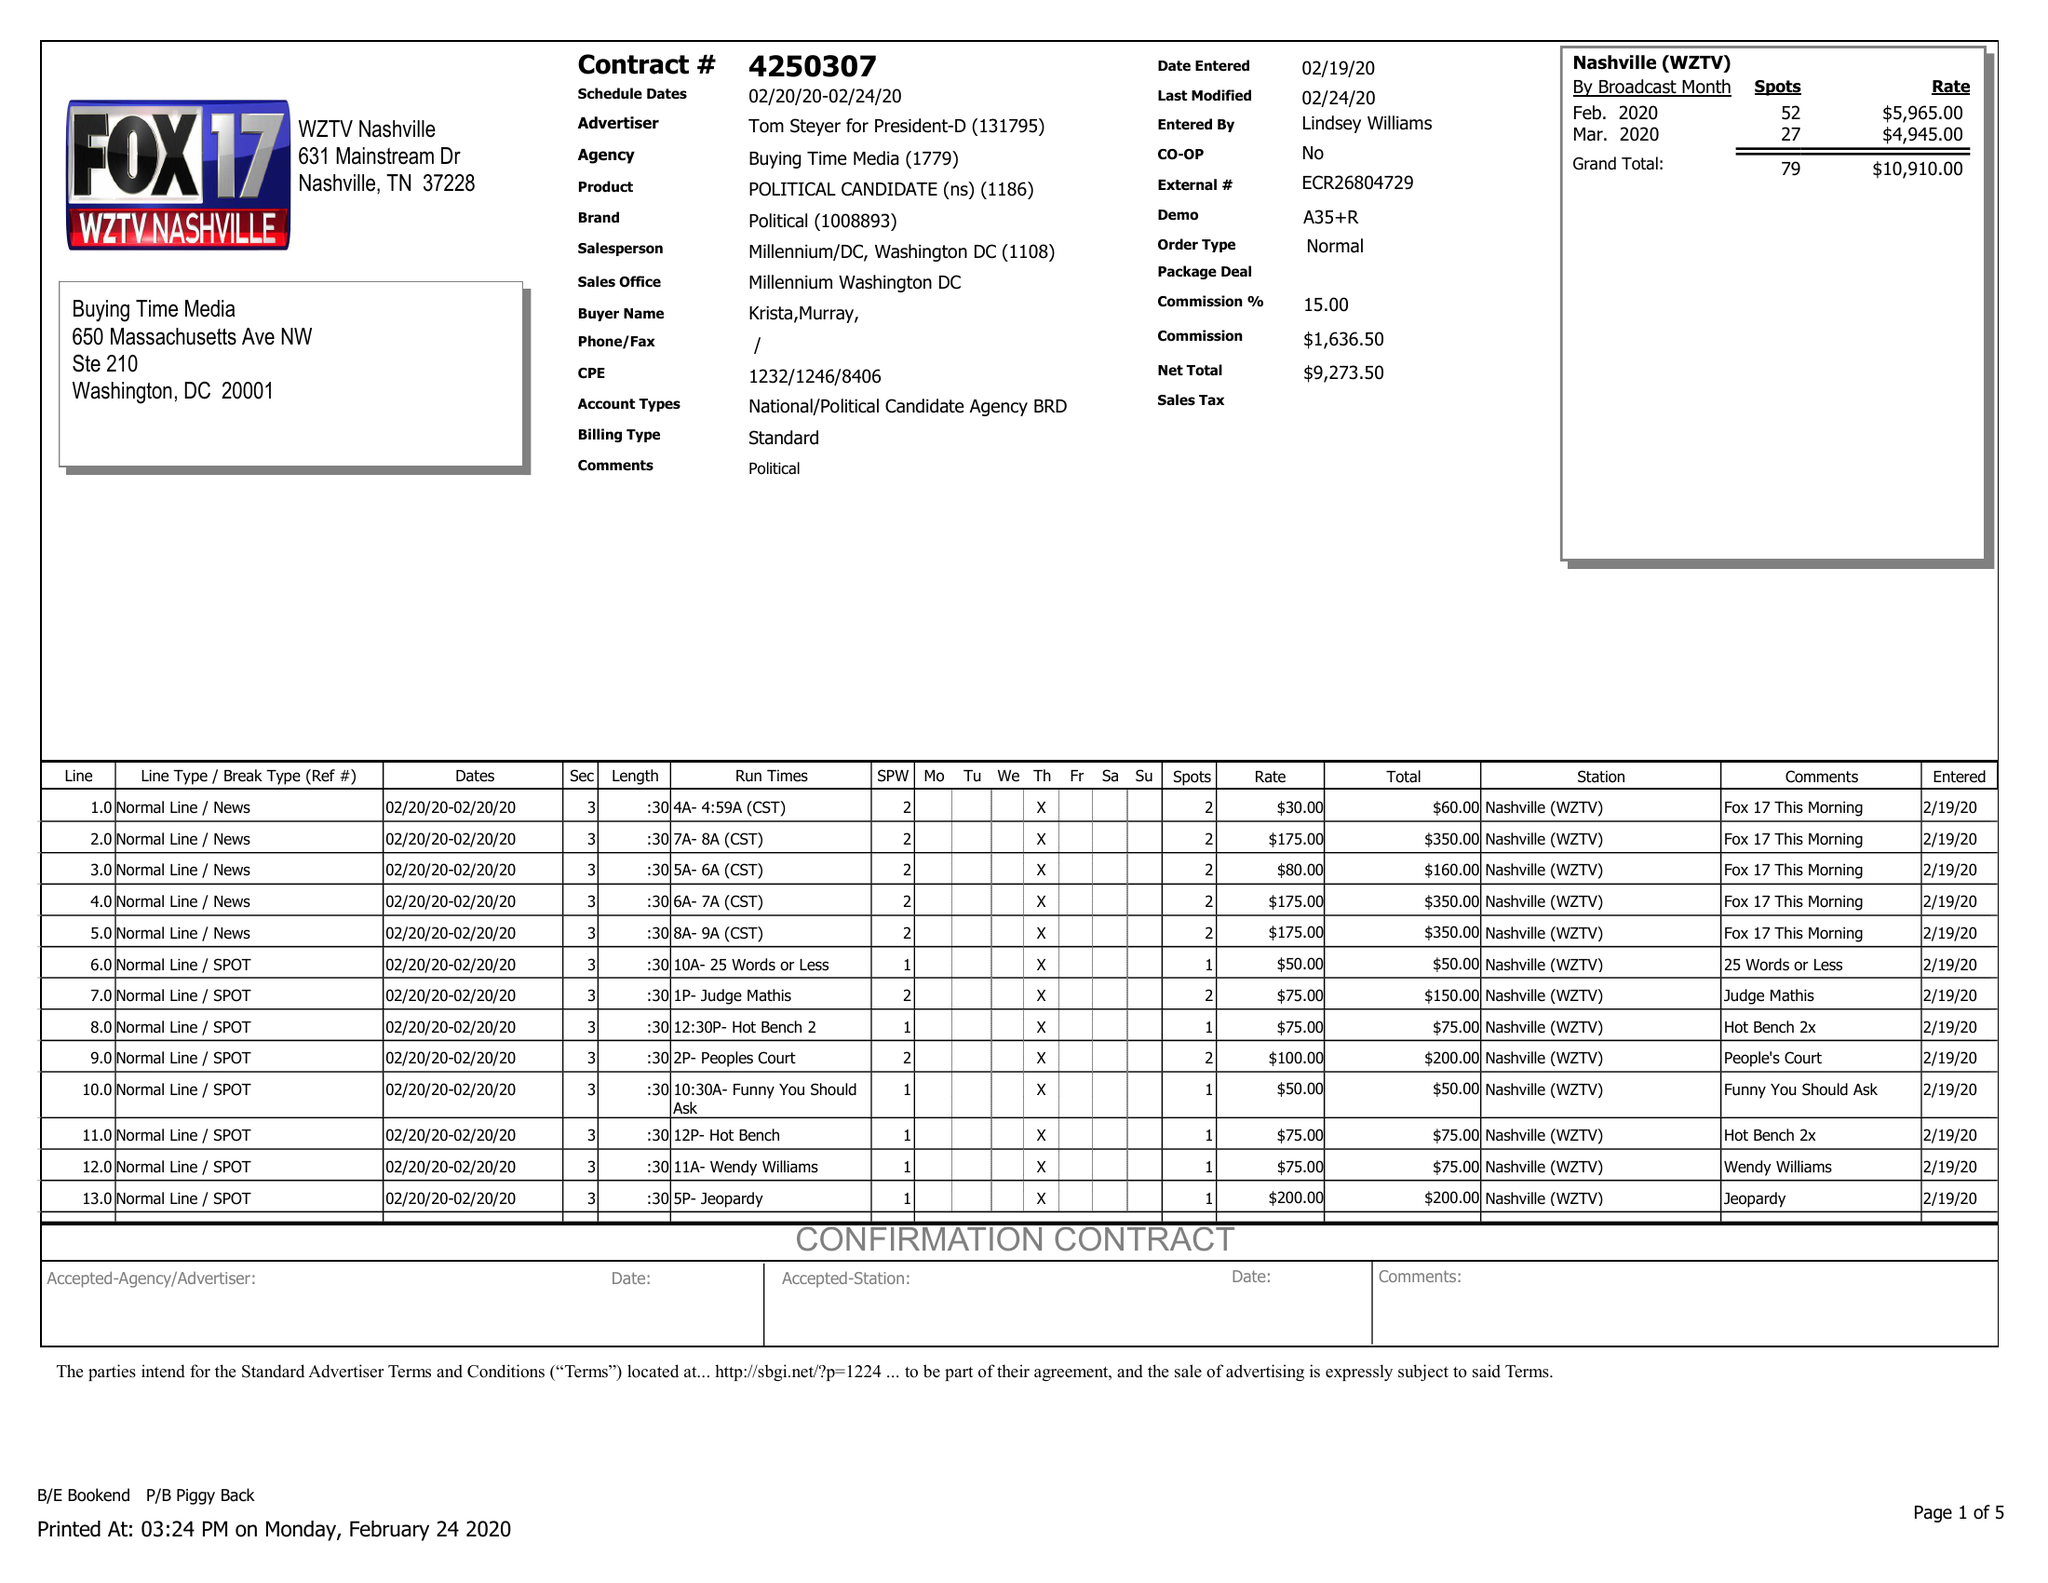What is the value for the flight_to?
Answer the question using a single word or phrase. 02/24/20 